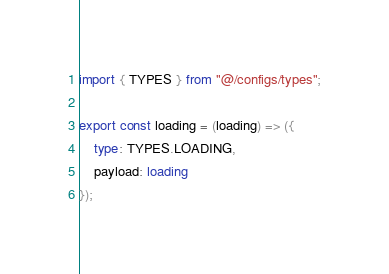<code> <loc_0><loc_0><loc_500><loc_500><_TypeScript_>import { TYPES } from "@/configs/types";

export const loading = (loading) => ({
    type: TYPES.LOADING,
	payload: loading
});</code> 